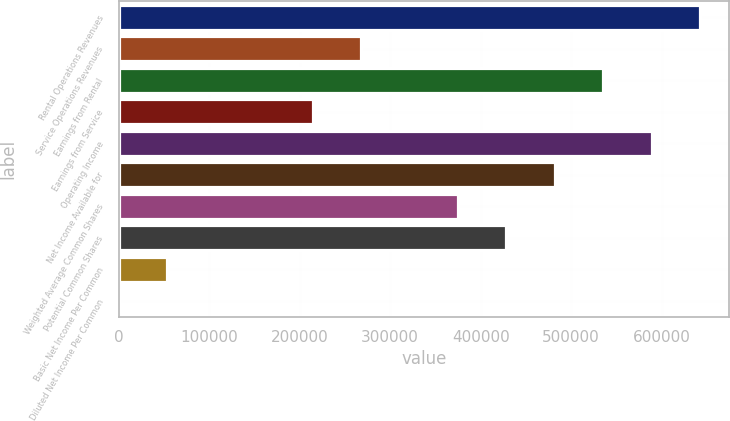<chart> <loc_0><loc_0><loc_500><loc_500><bar_chart><fcel>Rental Operations Revenues<fcel>Service Operations Revenues<fcel>Earnings from Rental<fcel>Earnings from Service<fcel>Operating Income<fcel>Net Income Available for<fcel>Weighted Average Common Shares<fcel>Potential Common Shares<fcel>Basic Net Income Per Common<fcel>Diluted Net Income Per Common<nl><fcel>642675<fcel>267782<fcel>535563<fcel>214226<fcel>589119<fcel>482007<fcel>374895<fcel>428451<fcel>53557.5<fcel>1.32<nl></chart> 